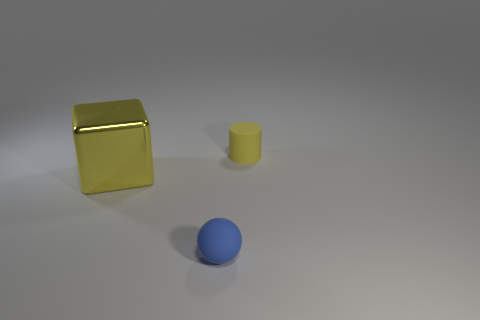What number of small yellow cylinders are there? There is one small yellow cylinder visible in the image, placed to the right of a blue sphere and in front of a larger yellow cube. 